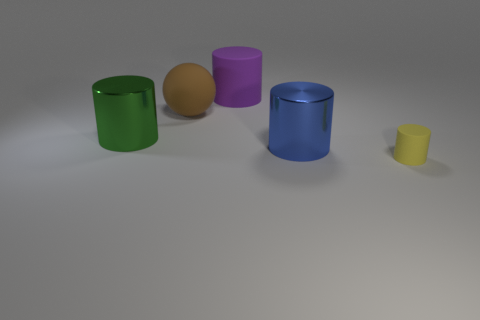Subtract all big green metal cylinders. How many cylinders are left? 3 Subtract 1 cylinders. How many cylinders are left? 3 Add 1 yellow matte things. How many objects exist? 6 Subtract all yellow cylinders. How many cylinders are left? 3 Subtract all balls. How many objects are left? 4 Subtract all green cubes. How many yellow cylinders are left? 1 Subtract all large matte objects. Subtract all tiny brown things. How many objects are left? 3 Add 5 large metallic objects. How many large metallic objects are left? 7 Add 4 big brown rubber things. How many big brown rubber things exist? 5 Subtract 0 red blocks. How many objects are left? 5 